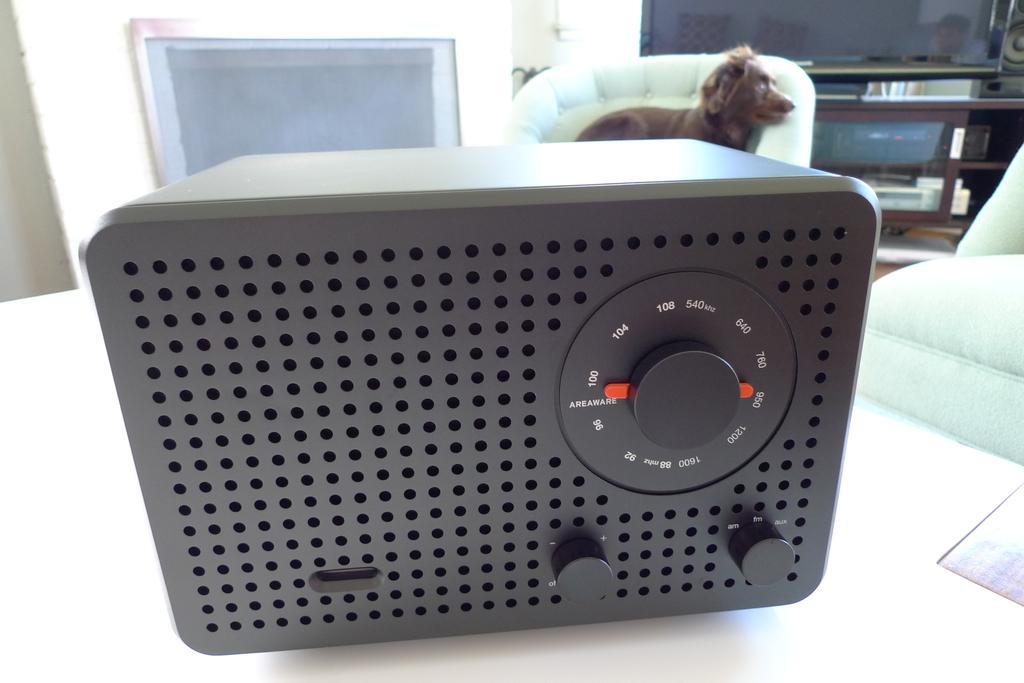Can you describe this image briefly? In this picture we can see a device on the platform and in the background we can see a dog and some objects. 